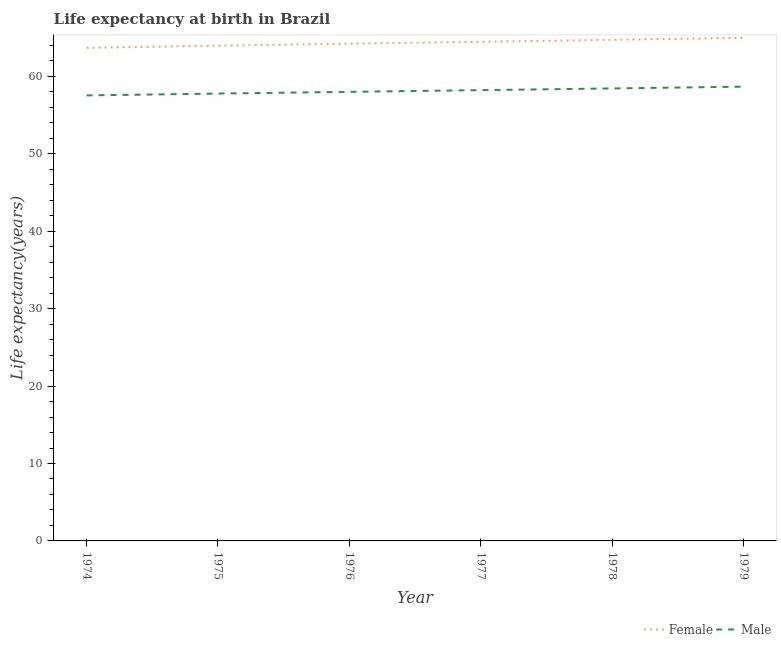Is the number of lines equal to the number of legend labels?
Provide a short and direct response. Yes. What is the life expectancy(male) in 1978?
Keep it short and to the point. 58.45. Across all years, what is the maximum life expectancy(female)?
Ensure brevity in your answer.  64.99. Across all years, what is the minimum life expectancy(male)?
Your answer should be compact. 57.55. In which year was the life expectancy(male) maximum?
Ensure brevity in your answer.  1979. In which year was the life expectancy(female) minimum?
Your answer should be compact. 1974. What is the total life expectancy(male) in the graph?
Keep it short and to the point. 348.67. What is the difference between the life expectancy(male) in 1975 and that in 1976?
Make the answer very short. -0.22. What is the difference between the life expectancy(male) in 1974 and the life expectancy(female) in 1978?
Ensure brevity in your answer.  -7.18. What is the average life expectancy(female) per year?
Provide a short and direct response. 64.34. In the year 1974, what is the difference between the life expectancy(female) and life expectancy(male)?
Ensure brevity in your answer.  6.14. What is the ratio of the life expectancy(male) in 1974 to that in 1979?
Make the answer very short. 0.98. Is the difference between the life expectancy(male) in 1974 and 1978 greater than the difference between the life expectancy(female) in 1974 and 1978?
Make the answer very short. Yes. What is the difference between the highest and the second highest life expectancy(male)?
Ensure brevity in your answer.  0.23. What is the difference between the highest and the lowest life expectancy(male)?
Make the answer very short. 1.13. Is the sum of the life expectancy(female) in 1974 and 1979 greater than the maximum life expectancy(male) across all years?
Offer a very short reply. Yes. Is the life expectancy(female) strictly greater than the life expectancy(male) over the years?
Provide a succinct answer. Yes. Is the life expectancy(male) strictly less than the life expectancy(female) over the years?
Give a very brief answer. Yes. Does the graph contain any zero values?
Your answer should be compact. No. Does the graph contain grids?
Your answer should be compact. No. How are the legend labels stacked?
Provide a short and direct response. Horizontal. What is the title of the graph?
Offer a terse response. Life expectancy at birth in Brazil. What is the label or title of the X-axis?
Give a very brief answer. Year. What is the label or title of the Y-axis?
Provide a short and direct response. Life expectancy(years). What is the Life expectancy(years) of Female in 1974?
Give a very brief answer. 63.69. What is the Life expectancy(years) in Male in 1974?
Your answer should be very brief. 57.55. What is the Life expectancy(years) of Female in 1975?
Give a very brief answer. 63.97. What is the Life expectancy(years) of Male in 1975?
Keep it short and to the point. 57.78. What is the Life expectancy(years) of Female in 1976?
Give a very brief answer. 64.23. What is the Life expectancy(years) of Male in 1976?
Offer a very short reply. 58. What is the Life expectancy(years) in Female in 1977?
Provide a succinct answer. 64.47. What is the Life expectancy(years) of Male in 1977?
Offer a terse response. 58.22. What is the Life expectancy(years) of Female in 1978?
Keep it short and to the point. 64.72. What is the Life expectancy(years) in Male in 1978?
Offer a very short reply. 58.45. What is the Life expectancy(years) of Female in 1979?
Ensure brevity in your answer.  64.99. What is the Life expectancy(years) of Male in 1979?
Your answer should be very brief. 58.67. Across all years, what is the maximum Life expectancy(years) of Female?
Offer a very short reply. 64.99. Across all years, what is the maximum Life expectancy(years) of Male?
Your response must be concise. 58.67. Across all years, what is the minimum Life expectancy(years) of Female?
Provide a succinct answer. 63.69. Across all years, what is the minimum Life expectancy(years) in Male?
Offer a very short reply. 57.55. What is the total Life expectancy(years) of Female in the graph?
Provide a short and direct response. 386.06. What is the total Life expectancy(years) in Male in the graph?
Your response must be concise. 348.67. What is the difference between the Life expectancy(years) of Female in 1974 and that in 1975?
Your response must be concise. -0.28. What is the difference between the Life expectancy(years) in Male in 1974 and that in 1975?
Ensure brevity in your answer.  -0.24. What is the difference between the Life expectancy(years) in Female in 1974 and that in 1976?
Provide a succinct answer. -0.54. What is the difference between the Life expectancy(years) in Male in 1974 and that in 1976?
Give a very brief answer. -0.46. What is the difference between the Life expectancy(years) of Female in 1974 and that in 1977?
Your response must be concise. -0.78. What is the difference between the Life expectancy(years) of Male in 1974 and that in 1977?
Make the answer very short. -0.68. What is the difference between the Life expectancy(years) of Female in 1974 and that in 1978?
Keep it short and to the point. -1.03. What is the difference between the Life expectancy(years) in Female in 1974 and that in 1979?
Your response must be concise. -1.3. What is the difference between the Life expectancy(years) in Male in 1974 and that in 1979?
Give a very brief answer. -1.13. What is the difference between the Life expectancy(years) of Female in 1975 and that in 1976?
Keep it short and to the point. -0.26. What is the difference between the Life expectancy(years) of Male in 1975 and that in 1976?
Make the answer very short. -0.22. What is the difference between the Life expectancy(years) of Female in 1975 and that in 1977?
Ensure brevity in your answer.  -0.5. What is the difference between the Life expectancy(years) of Male in 1975 and that in 1977?
Offer a very short reply. -0.44. What is the difference between the Life expectancy(years) of Female in 1975 and that in 1978?
Your response must be concise. -0.75. What is the difference between the Life expectancy(years) of Male in 1975 and that in 1978?
Offer a very short reply. -0.66. What is the difference between the Life expectancy(years) of Female in 1975 and that in 1979?
Offer a terse response. -1.02. What is the difference between the Life expectancy(years) of Male in 1975 and that in 1979?
Keep it short and to the point. -0.89. What is the difference between the Life expectancy(years) in Female in 1976 and that in 1977?
Offer a terse response. -0.24. What is the difference between the Life expectancy(years) of Male in 1976 and that in 1977?
Your response must be concise. -0.22. What is the difference between the Life expectancy(years) of Female in 1976 and that in 1978?
Your response must be concise. -0.49. What is the difference between the Life expectancy(years) in Male in 1976 and that in 1978?
Provide a short and direct response. -0.44. What is the difference between the Life expectancy(years) of Female in 1976 and that in 1979?
Offer a terse response. -0.76. What is the difference between the Life expectancy(years) in Male in 1976 and that in 1979?
Provide a succinct answer. -0.67. What is the difference between the Life expectancy(years) in Female in 1977 and that in 1978?
Give a very brief answer. -0.25. What is the difference between the Life expectancy(years) of Male in 1977 and that in 1978?
Make the answer very short. -0.22. What is the difference between the Life expectancy(years) in Female in 1977 and that in 1979?
Keep it short and to the point. -0.52. What is the difference between the Life expectancy(years) of Male in 1977 and that in 1979?
Your response must be concise. -0.45. What is the difference between the Life expectancy(years) in Female in 1978 and that in 1979?
Keep it short and to the point. -0.27. What is the difference between the Life expectancy(years) of Male in 1978 and that in 1979?
Provide a short and direct response. -0.23. What is the difference between the Life expectancy(years) in Female in 1974 and the Life expectancy(years) in Male in 1975?
Make the answer very short. 5.91. What is the difference between the Life expectancy(years) of Female in 1974 and the Life expectancy(years) of Male in 1976?
Offer a terse response. 5.68. What is the difference between the Life expectancy(years) of Female in 1974 and the Life expectancy(years) of Male in 1977?
Ensure brevity in your answer.  5.46. What is the difference between the Life expectancy(years) in Female in 1974 and the Life expectancy(years) in Male in 1978?
Ensure brevity in your answer.  5.24. What is the difference between the Life expectancy(years) in Female in 1974 and the Life expectancy(years) in Male in 1979?
Ensure brevity in your answer.  5.01. What is the difference between the Life expectancy(years) of Female in 1975 and the Life expectancy(years) of Male in 1976?
Provide a short and direct response. 5.97. What is the difference between the Life expectancy(years) of Female in 1975 and the Life expectancy(years) of Male in 1977?
Provide a short and direct response. 5.75. What is the difference between the Life expectancy(years) in Female in 1975 and the Life expectancy(years) in Male in 1978?
Offer a very short reply. 5.53. What is the difference between the Life expectancy(years) in Female in 1975 and the Life expectancy(years) in Male in 1979?
Provide a succinct answer. 5.3. What is the difference between the Life expectancy(years) of Female in 1976 and the Life expectancy(years) of Male in 1977?
Ensure brevity in your answer.  6. What is the difference between the Life expectancy(years) in Female in 1976 and the Life expectancy(years) in Male in 1978?
Offer a very short reply. 5.78. What is the difference between the Life expectancy(years) of Female in 1976 and the Life expectancy(years) of Male in 1979?
Keep it short and to the point. 5.55. What is the difference between the Life expectancy(years) in Female in 1977 and the Life expectancy(years) in Male in 1978?
Give a very brief answer. 6.03. What is the difference between the Life expectancy(years) of Female in 1977 and the Life expectancy(years) of Male in 1979?
Offer a terse response. 5.8. What is the difference between the Life expectancy(years) in Female in 1978 and the Life expectancy(years) in Male in 1979?
Make the answer very short. 6.05. What is the average Life expectancy(years) of Female per year?
Make the answer very short. 64.34. What is the average Life expectancy(years) in Male per year?
Provide a succinct answer. 58.11. In the year 1974, what is the difference between the Life expectancy(years) of Female and Life expectancy(years) of Male?
Offer a very short reply. 6.14. In the year 1975, what is the difference between the Life expectancy(years) of Female and Life expectancy(years) of Male?
Provide a succinct answer. 6.19. In the year 1976, what is the difference between the Life expectancy(years) of Female and Life expectancy(years) of Male?
Provide a succinct answer. 6.22. In the year 1977, what is the difference between the Life expectancy(years) in Female and Life expectancy(years) in Male?
Offer a very short reply. 6.25. In the year 1978, what is the difference between the Life expectancy(years) in Female and Life expectancy(years) in Male?
Your answer should be compact. 6.28. In the year 1979, what is the difference between the Life expectancy(years) of Female and Life expectancy(years) of Male?
Offer a very short reply. 6.32. What is the ratio of the Life expectancy(years) of Female in 1974 to that in 1976?
Give a very brief answer. 0.99. What is the ratio of the Life expectancy(years) of Male in 1974 to that in 1976?
Make the answer very short. 0.99. What is the ratio of the Life expectancy(years) in Female in 1974 to that in 1977?
Offer a very short reply. 0.99. What is the ratio of the Life expectancy(years) of Male in 1974 to that in 1977?
Offer a very short reply. 0.99. What is the ratio of the Life expectancy(years) of Male in 1974 to that in 1978?
Ensure brevity in your answer.  0.98. What is the ratio of the Life expectancy(years) of Female in 1974 to that in 1979?
Your answer should be very brief. 0.98. What is the ratio of the Life expectancy(years) of Male in 1974 to that in 1979?
Provide a short and direct response. 0.98. What is the ratio of the Life expectancy(years) of Female in 1975 to that in 1977?
Provide a short and direct response. 0.99. What is the ratio of the Life expectancy(years) of Male in 1975 to that in 1977?
Offer a very short reply. 0.99. What is the ratio of the Life expectancy(years) in Female in 1975 to that in 1978?
Keep it short and to the point. 0.99. What is the ratio of the Life expectancy(years) in Male in 1975 to that in 1978?
Give a very brief answer. 0.99. What is the ratio of the Life expectancy(years) of Female in 1975 to that in 1979?
Your response must be concise. 0.98. What is the ratio of the Life expectancy(years) of Female in 1976 to that in 1978?
Your answer should be compact. 0.99. What is the ratio of the Life expectancy(years) in Male in 1976 to that in 1978?
Your answer should be compact. 0.99. What is the ratio of the Life expectancy(years) of Female in 1976 to that in 1979?
Offer a terse response. 0.99. What is the ratio of the Life expectancy(years) in Male in 1976 to that in 1979?
Offer a terse response. 0.99. What is the ratio of the Life expectancy(years) of Male in 1977 to that in 1978?
Offer a very short reply. 1. What is the ratio of the Life expectancy(years) in Male in 1977 to that in 1979?
Your answer should be compact. 0.99. What is the ratio of the Life expectancy(years) in Male in 1978 to that in 1979?
Keep it short and to the point. 1. What is the difference between the highest and the second highest Life expectancy(years) in Female?
Your answer should be compact. 0.27. What is the difference between the highest and the second highest Life expectancy(years) in Male?
Provide a succinct answer. 0.23. What is the difference between the highest and the lowest Life expectancy(years) in Female?
Offer a terse response. 1.3. What is the difference between the highest and the lowest Life expectancy(years) of Male?
Provide a short and direct response. 1.13. 